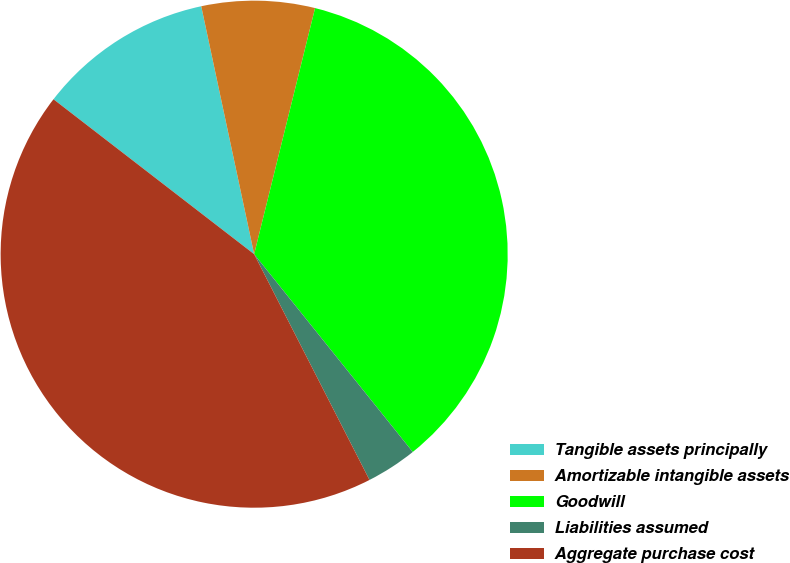Convert chart. <chart><loc_0><loc_0><loc_500><loc_500><pie_chart><fcel>Tangible assets principally<fcel>Amortizable intangible assets<fcel>Goodwill<fcel>Liabilities assumed<fcel>Aggregate purchase cost<nl><fcel>11.19%<fcel>7.21%<fcel>35.38%<fcel>3.24%<fcel>42.98%<nl></chart> 